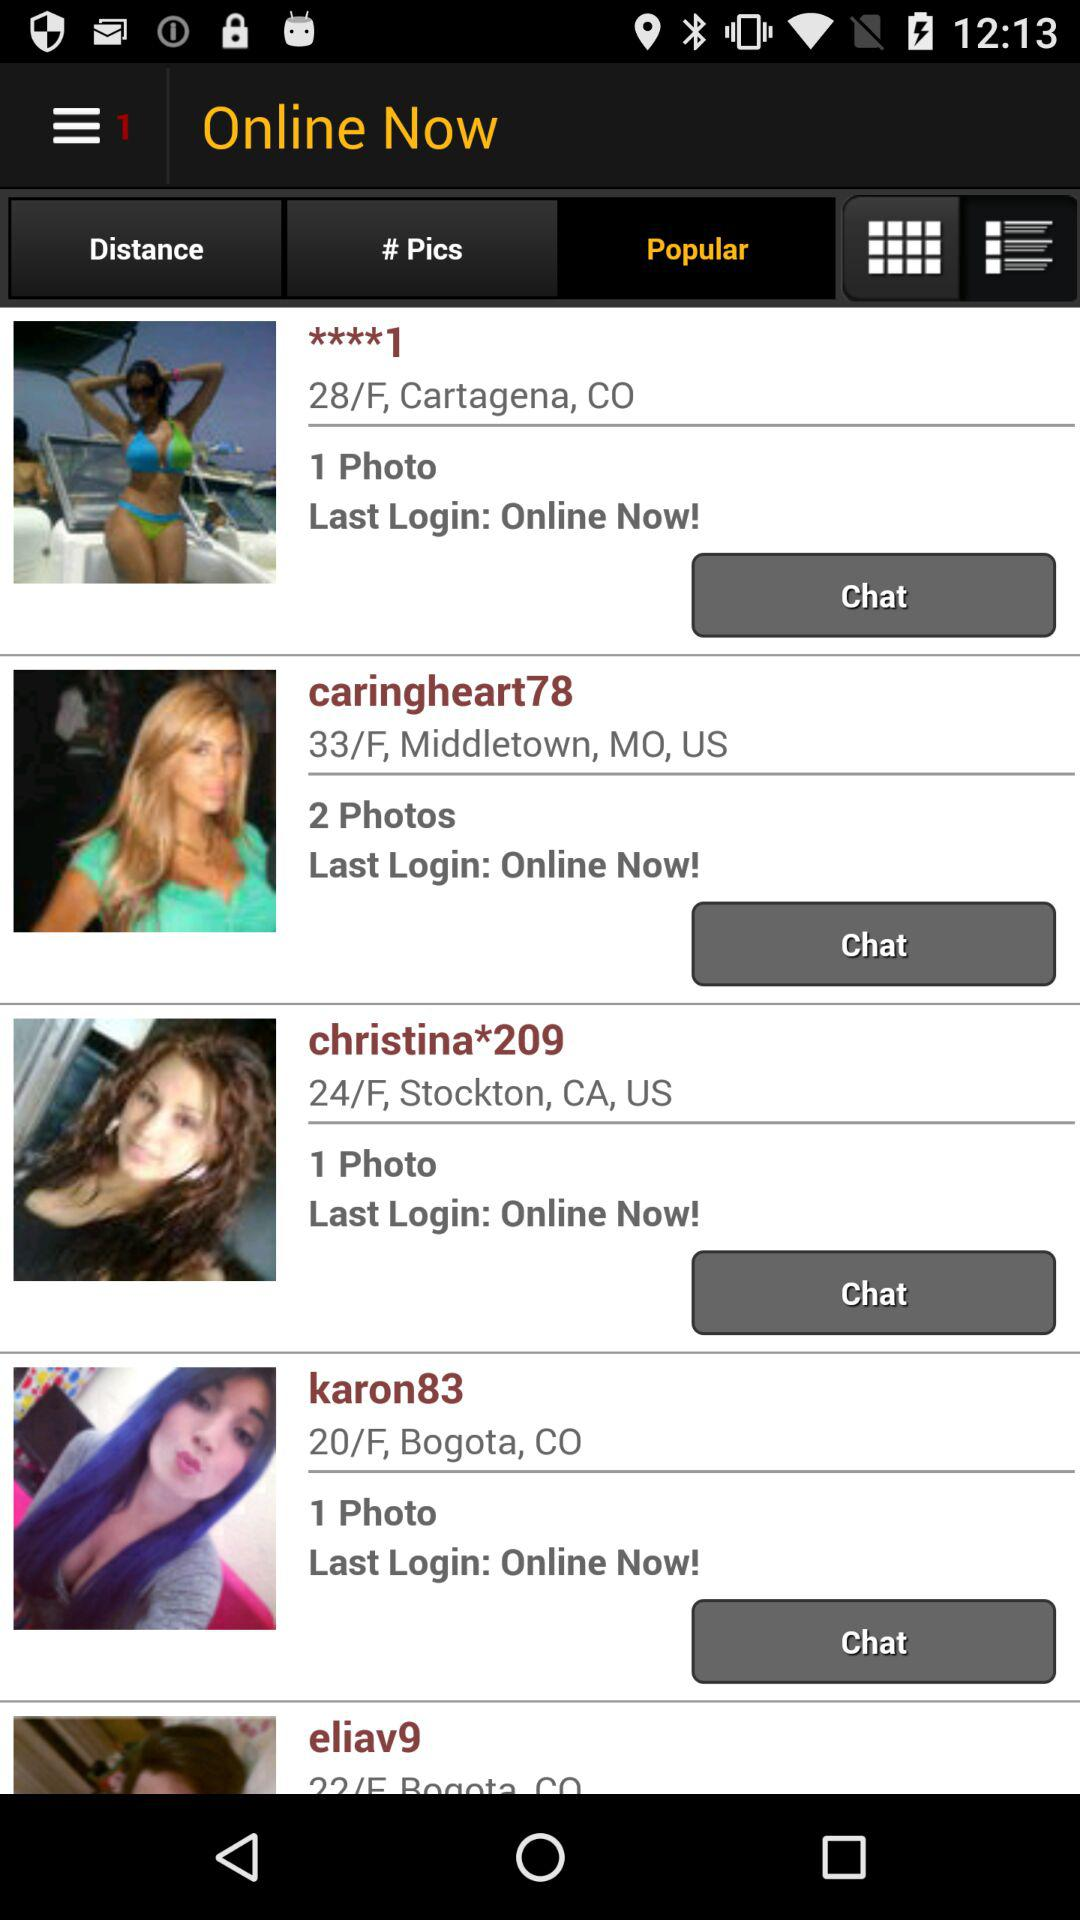What's the gender of "caringheart78"? The gender of "caringheart78" is female. 